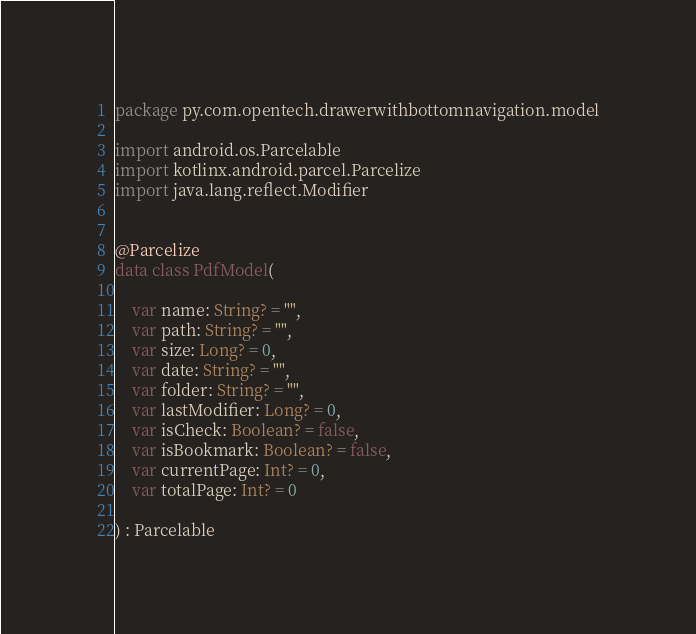<code> <loc_0><loc_0><loc_500><loc_500><_Kotlin_>package py.com.opentech.drawerwithbottomnavigation.model

import android.os.Parcelable
import kotlinx.android.parcel.Parcelize
import java.lang.reflect.Modifier


@Parcelize
data class PdfModel(

    var name: String? = "",
    var path: String? = "",
    var size: Long? = 0,
    var date: String? = "",
    var folder: String? = "",
    var lastModifier: Long? = 0,
    var isCheck: Boolean? = false,
    var isBookmark: Boolean? = false,
    var currentPage: Int? = 0,
    var totalPage: Int? = 0

) : Parcelable</code> 